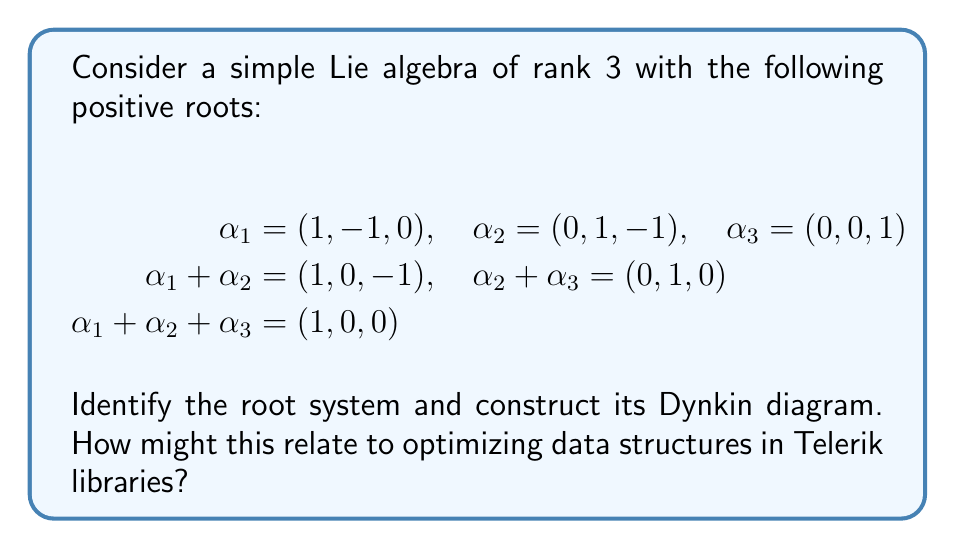Teach me how to tackle this problem. To identify the root system and construct the Dynkin diagram, we'll follow these steps:

1. Identify the simple roots:
   The simple roots are $\alpha_1 = (1, -1, 0)$, $\alpha_2 = (0, 1, -1)$, and $\alpha_3 = (0, 0, 1)$.

2. Calculate the Cartan matrix:
   We need to compute $\langle \alpha_i, \alpha_j^\vee \rangle$ for each pair of simple roots.
   $\alpha_i^\vee = \frac{2\alpha_i}{\langle \alpha_i, \alpha_i \rangle}$

   $\langle \alpha_1, \alpha_1 \rangle = 2$
   $\langle \alpha_1, \alpha_2 \rangle = -1$
   $\langle \alpha_1, \alpha_3 \rangle = 0$
   $\langle \alpha_2, \alpha_1 \rangle = -1$
   $\langle \alpha_2, \alpha_2 \rangle = 2$
   $\langle \alpha_2, \alpha_3 \rangle = -1$
   $\langle \alpha_3, \alpha_1 \rangle = 0$
   $\langle \alpha_3, \alpha_2 \rangle = -1$
   $\langle \alpha_3, \alpha_3 \rangle = 1$

   The Cartan matrix is:
   $$ A = \begin{pmatrix}
   2 & -1 & 0 \\
   -1 & 2 & -1 \\
   0 & -1 & 2
   \end{pmatrix} $$

3. Construct the Dynkin diagram:
   - Draw a node for each simple root.
   - Connect nodes i and j with $|\langle \alpha_i, \alpha_j^\vee \rangle| \cdot |\langle \alpha_j, \alpha_i^\vee \rangle|$ lines.
   - If $|\langle \alpha_i, \alpha_j^\vee \rangle| > |\langle \alpha_j, \alpha_i^\vee \rangle|$, add an arrow pointing from node j to node i.

   [asy]
   unitsize(1cm);
   dot((0,0)); dot((1,0)); dot((2,0));
   draw((0,0)--(2,0));
   label("$\alpha_1$", (0,0), S);
   label("$\alpha_2$", (1,0), S);
   label("$\alpha_3$", (2,0), S);
   [/asy]

4. Identify the root system:
   The Dynkin diagram corresponds to the $A_3$ root system, which is associated with the Lie algebra $\mathfrak{sl}(4, \mathbb{C})$ or $SU(4)$.

Relating this to optimizing data structures in Telerik libraries:
The structure of the $A_3$ root system can be analogous to organizing hierarchical data in software. Just as the simple roots form the basis for the entire root system, fundamental data structures in Telerik libraries can be optimized to efficiently represent more complex data relationships. The connections in the Dynkin diagram can represent relationships between different data components, guiding the design of efficient algorithms for traversing and manipulating data structures.
Answer: The root system is $A_3$, and the Dynkin diagram is a linear chain of three nodes connected by single edges. This corresponds to the Lie algebra $\mathfrak{sl}(4, \mathbb{C})$ or $SU(4)$. 